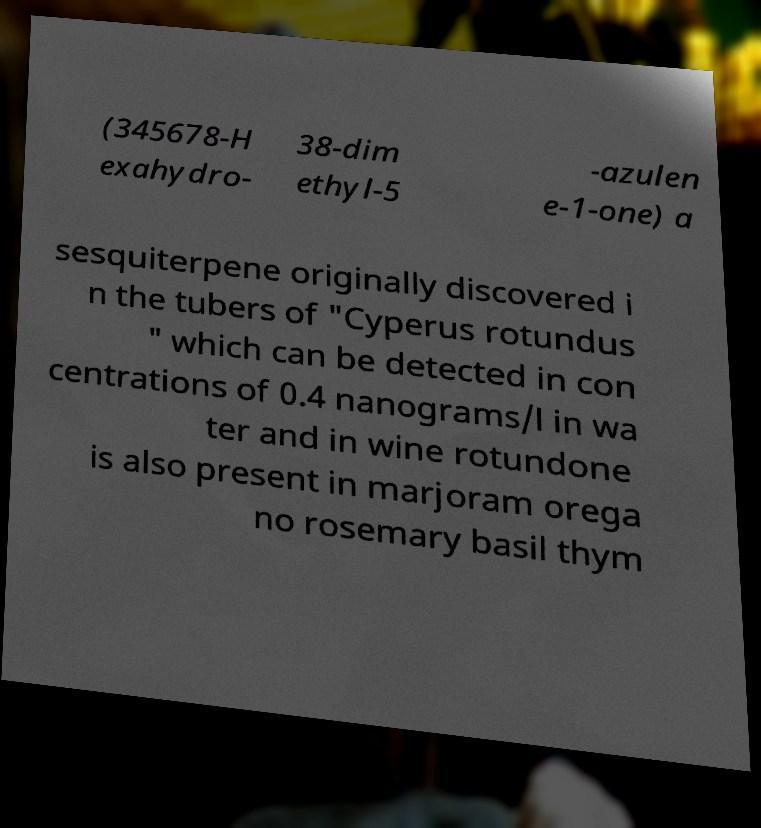For documentation purposes, I need the text within this image transcribed. Could you provide that? (345678-H exahydro- 38-dim ethyl-5 -azulen e-1-one) a sesquiterpene originally discovered i n the tubers of "Cyperus rotundus " which can be detected in con centrations of 0.4 nanograms/l in wa ter and in wine rotundone is also present in marjoram orega no rosemary basil thym 